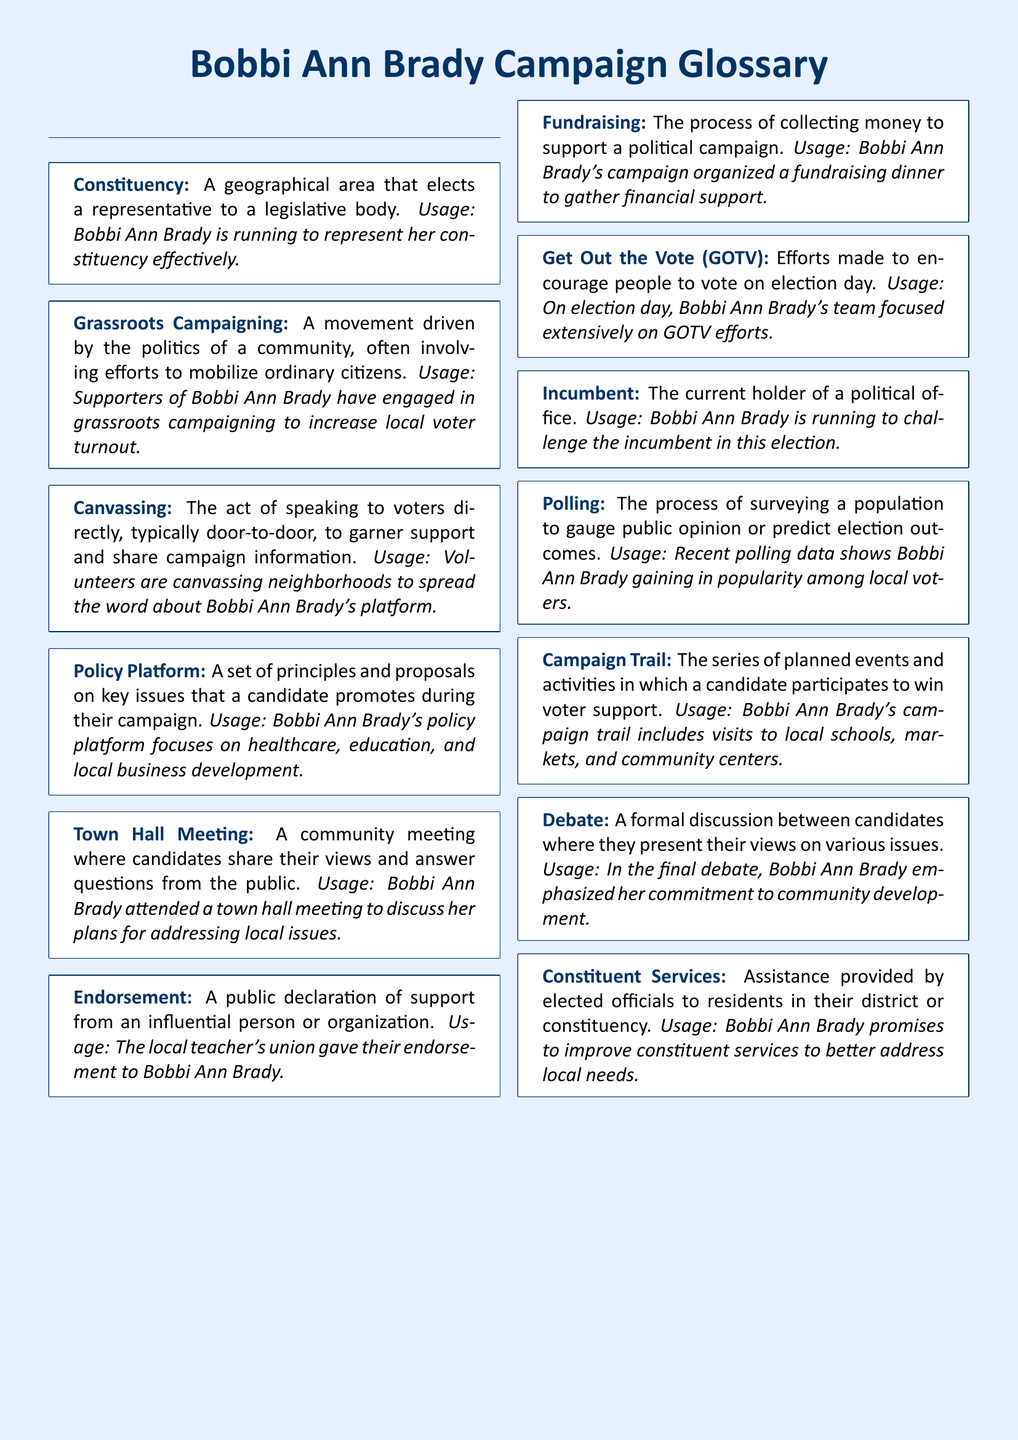What is the term for a geographical area that elects a representative? The term is defined within the glossary, specifying that it relates to the political representation of an area.
Answer: Constituency What does Bobbi Ann Brady's policy platform focus on? The document details the key issues included in Bobbi Ann Brady's campaign proposals as part of her platform.
Answer: Healthcare, education, and local business development What is canvassing? The glossary explains canvassing as the action of communicating directly with voters to gather support and share information.
Answer: Speaking to voters directly What did the local teacher's union do for Bobbi Ann Brady? The document mentions an action taken by the local teacher's union that is significant for campaign support.
Answer: Gave their endorsement What type of meeting allows candidates to discuss their plans with the community? The glossary includes a specific type of meeting where public engagement occurs with candidates.
Answer: Town Hall Meeting How does Bobbi Ann Brady plan to improve public engagement? The explanation in the glossary highlights activities aimed at enhancing voter participation.
Answer: Get Out the Vote (GOTV) What is the role of an incumbent in an election? The document defines the term specifically related to those currently holding political office.
Answer: Current holder of a political office What is the purpose of fundraising in a campaign? The glossary outlines fundraising as a crucial activity that supports the financial needs of a campaign.
Answer: Collecting money to support a political campaign 